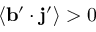Convert formula to latex. <formula><loc_0><loc_0><loc_500><loc_500>\langle { { b } ^ { \prime } \cdot { j } ^ { \prime } } \rangle > 0</formula> 